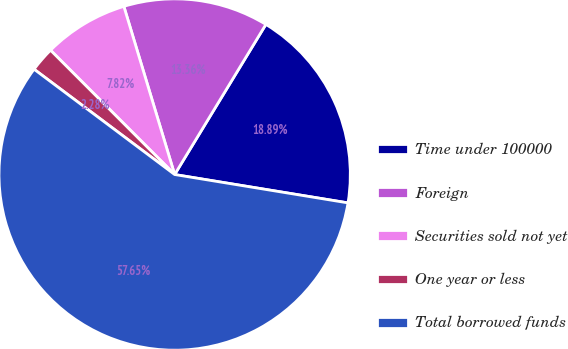Convert chart to OTSL. <chart><loc_0><loc_0><loc_500><loc_500><pie_chart><fcel>Time under 100000<fcel>Foreign<fcel>Securities sold not yet<fcel>One year or less<fcel>Total borrowed funds<nl><fcel>18.89%<fcel>13.36%<fcel>7.82%<fcel>2.28%<fcel>57.65%<nl></chart> 